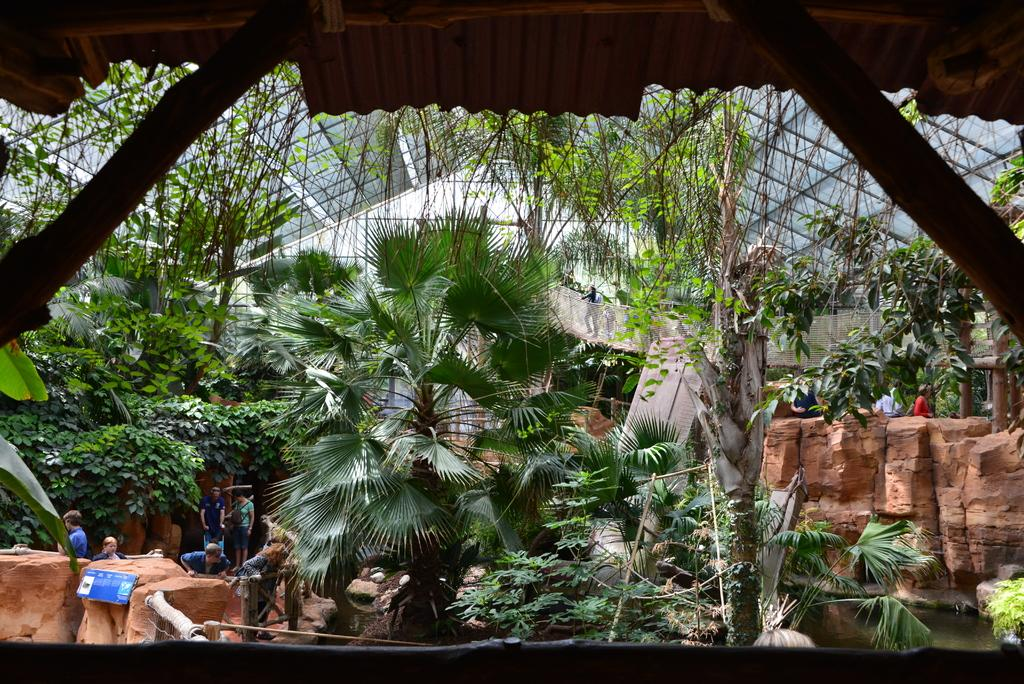What type of natural elements can be seen in the image? There are plants and trees in the image. What type of structure is visible in the image? There is a wall visible in the image. What is the water element in the image used for? The water in the image is not explicitly used for anything, but it is present. What type of building is located at the top of the image? There is a shed at the top of the image. Who is present in the image? There are people standing in the image. What type of oven is being used by the uncle in the image? There is no uncle or oven present in the image. How are the people sorting the plants in the image? There is no indication in the image that the people are sorting plants. 